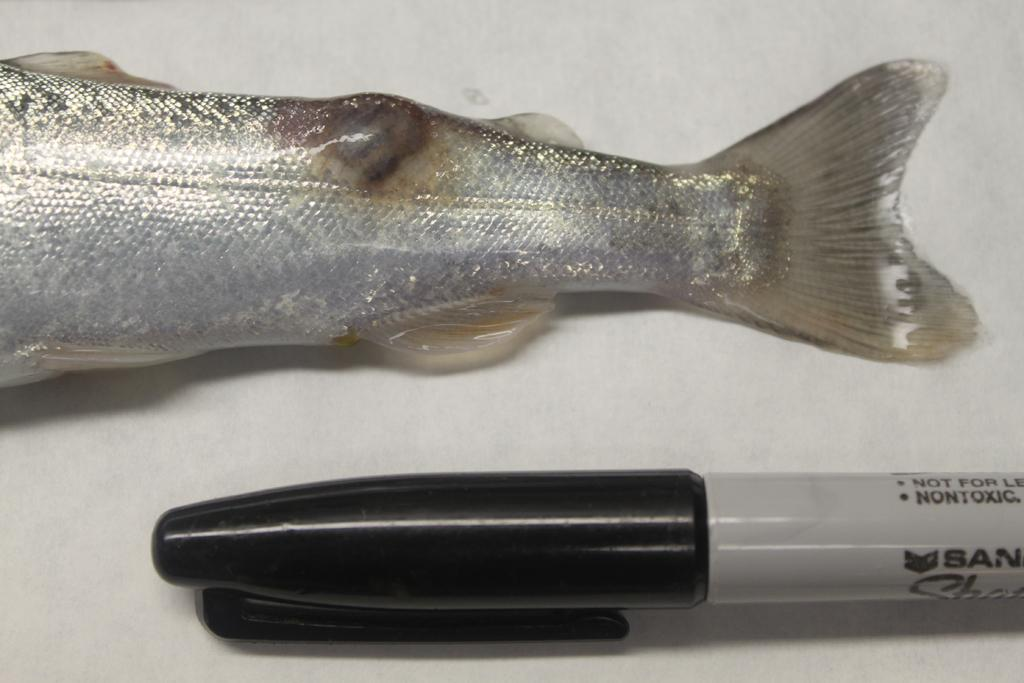What is the main subject of the image? The main subject of the image is a fish on a table. What is located beside the fish on the table? There is a marker beside the fish on the table. What type of popcorn is being served at the school's authority meeting in the image? There is no popcorn, school, or authority meeting present in the image; it features a fish on a table with a marker beside it. 